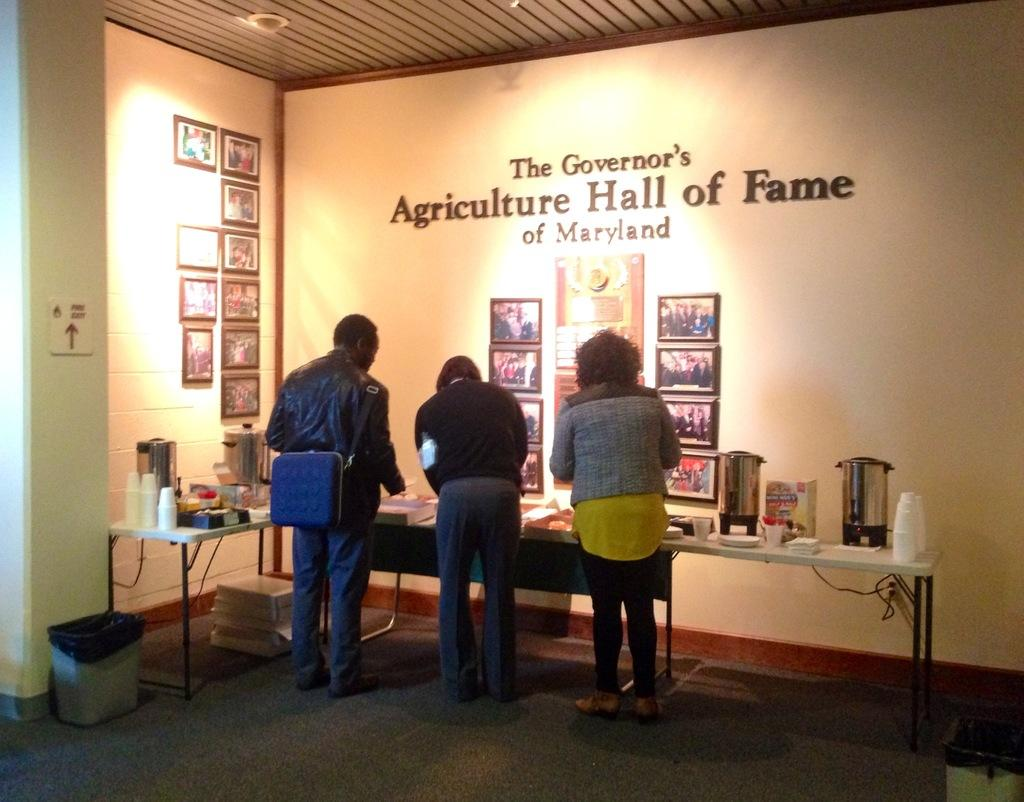<image>
Create a compact narrative representing the image presented. Three people stand at a desk in the Agriculture Hall of Fame 